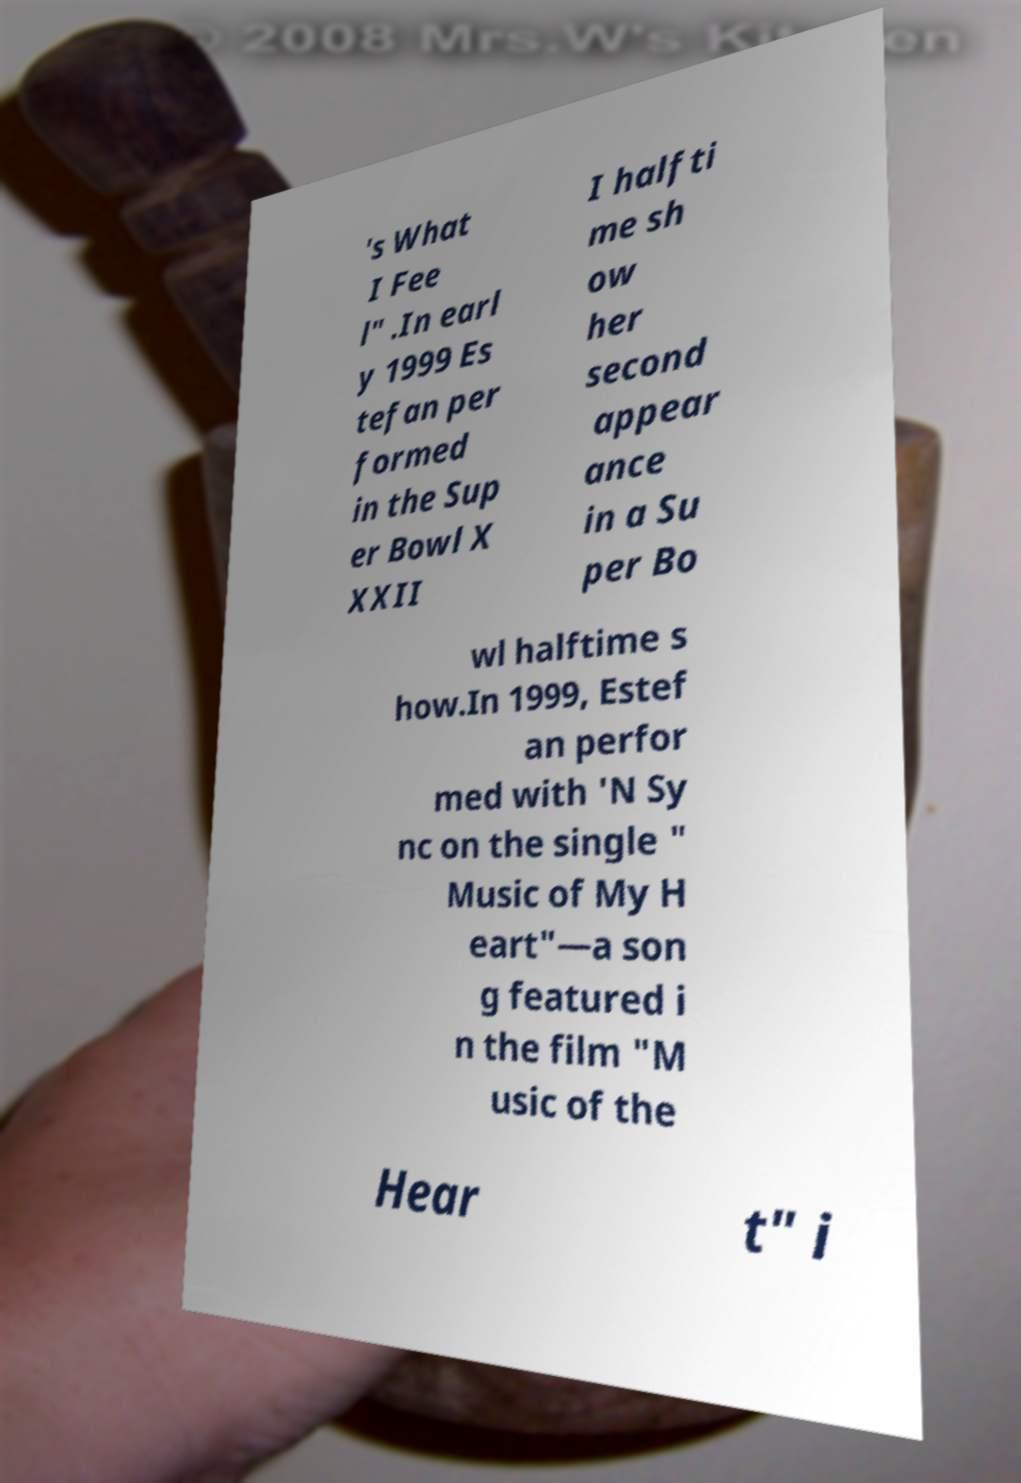Can you accurately transcribe the text from the provided image for me? 's What I Fee l" .In earl y 1999 Es tefan per formed in the Sup er Bowl X XXII I halfti me sh ow her second appear ance in a Su per Bo wl halftime s how.In 1999, Estef an perfor med with 'N Sy nc on the single " Music of My H eart"—a son g featured i n the film "M usic of the Hear t" i 